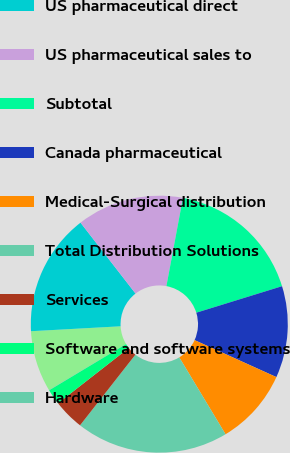Convert chart to OTSL. <chart><loc_0><loc_0><loc_500><loc_500><pie_chart><fcel>(In millions)<fcel>US pharmaceutical direct<fcel>US pharmaceutical sales to<fcel>Subtotal<fcel>Canada pharmaceutical<fcel>Medical-Surgical distribution<fcel>Total Distribution Solutions<fcel>Services<fcel>Software and software systems<fcel>Hardware<nl><fcel>7.7%<fcel>15.37%<fcel>13.45%<fcel>17.28%<fcel>11.53%<fcel>9.62%<fcel>19.2%<fcel>3.87%<fcel>1.95%<fcel>0.03%<nl></chart> 